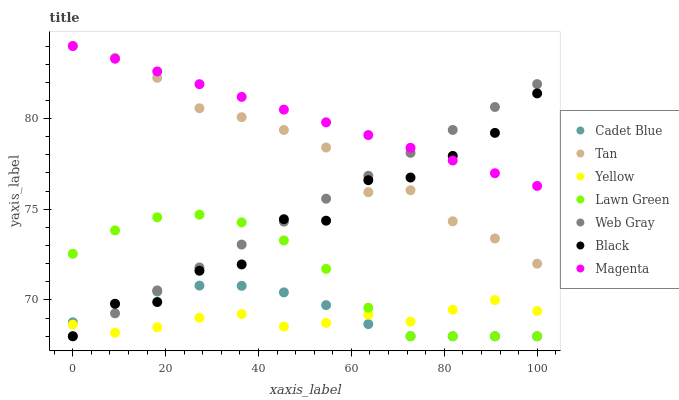Does Yellow have the minimum area under the curve?
Answer yes or no. Yes. Does Magenta have the maximum area under the curve?
Answer yes or no. Yes. Does Cadet Blue have the minimum area under the curve?
Answer yes or no. No. Does Cadet Blue have the maximum area under the curve?
Answer yes or no. No. Is Web Gray the smoothest?
Answer yes or no. Yes. Is Black the roughest?
Answer yes or no. Yes. Is Cadet Blue the smoothest?
Answer yes or no. No. Is Cadet Blue the roughest?
Answer yes or no. No. Does Lawn Green have the lowest value?
Answer yes or no. Yes. Does Yellow have the lowest value?
Answer yes or no. No. Does Magenta have the highest value?
Answer yes or no. Yes. Does Cadet Blue have the highest value?
Answer yes or no. No. Is Lawn Green less than Tan?
Answer yes or no. Yes. Is Magenta greater than Lawn Green?
Answer yes or no. Yes. Does Yellow intersect Lawn Green?
Answer yes or no. Yes. Is Yellow less than Lawn Green?
Answer yes or no. No. Is Yellow greater than Lawn Green?
Answer yes or no. No. Does Lawn Green intersect Tan?
Answer yes or no. No. 